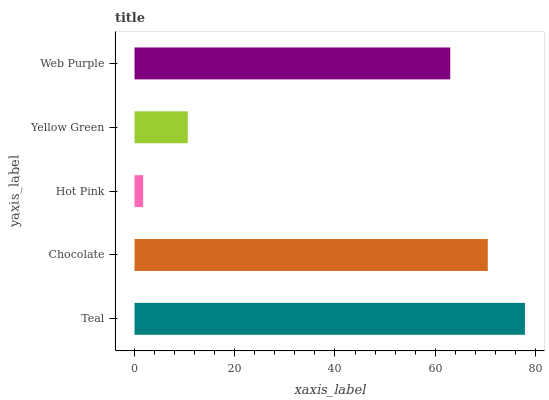Is Hot Pink the minimum?
Answer yes or no. Yes. Is Teal the maximum?
Answer yes or no. Yes. Is Chocolate the minimum?
Answer yes or no. No. Is Chocolate the maximum?
Answer yes or no. No. Is Teal greater than Chocolate?
Answer yes or no. Yes. Is Chocolate less than Teal?
Answer yes or no. Yes. Is Chocolate greater than Teal?
Answer yes or no. No. Is Teal less than Chocolate?
Answer yes or no. No. Is Web Purple the high median?
Answer yes or no. Yes. Is Web Purple the low median?
Answer yes or no. Yes. Is Hot Pink the high median?
Answer yes or no. No. Is Yellow Green the low median?
Answer yes or no. No. 